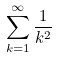Convert formula to latex. <formula><loc_0><loc_0><loc_500><loc_500>\sum _ { k = 1 } ^ { \infty } \frac { 1 } { k ^ { 2 } }</formula> 